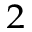Convert formula to latex. <formula><loc_0><loc_0><loc_500><loc_500>_ { 2 }</formula> 